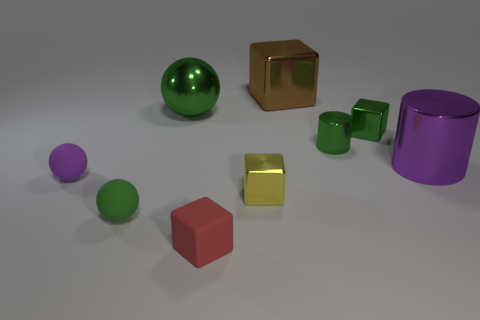Do the brown metallic object and the green shiny object that is right of the green shiny cylinder have the same shape?
Keep it short and to the point. Yes. What number of objects are either small cyan cylinders or cylinders left of the green metallic block?
Make the answer very short. 1. There is a brown object that is the same shape as the yellow shiny thing; what is it made of?
Your answer should be compact. Metal. There is a purple thing that is right of the tiny yellow shiny block; does it have the same shape as the brown metal thing?
Keep it short and to the point. No. Is there anything else that has the same size as the red rubber cube?
Provide a short and direct response. Yes. Is the number of brown metallic things that are in front of the small red block less than the number of shiny cubes behind the metal ball?
Provide a succinct answer. Yes. How many other things are there of the same shape as the green rubber thing?
Keep it short and to the point. 2. What is the size of the cylinder that is to the right of the cylinder to the left of the large cylinder behind the small green rubber ball?
Give a very brief answer. Large. How many blue things are balls or tiny balls?
Offer a terse response. 0. There is a green metallic thing left of the shiny block that is in front of the green cylinder; what shape is it?
Provide a succinct answer. Sphere. 